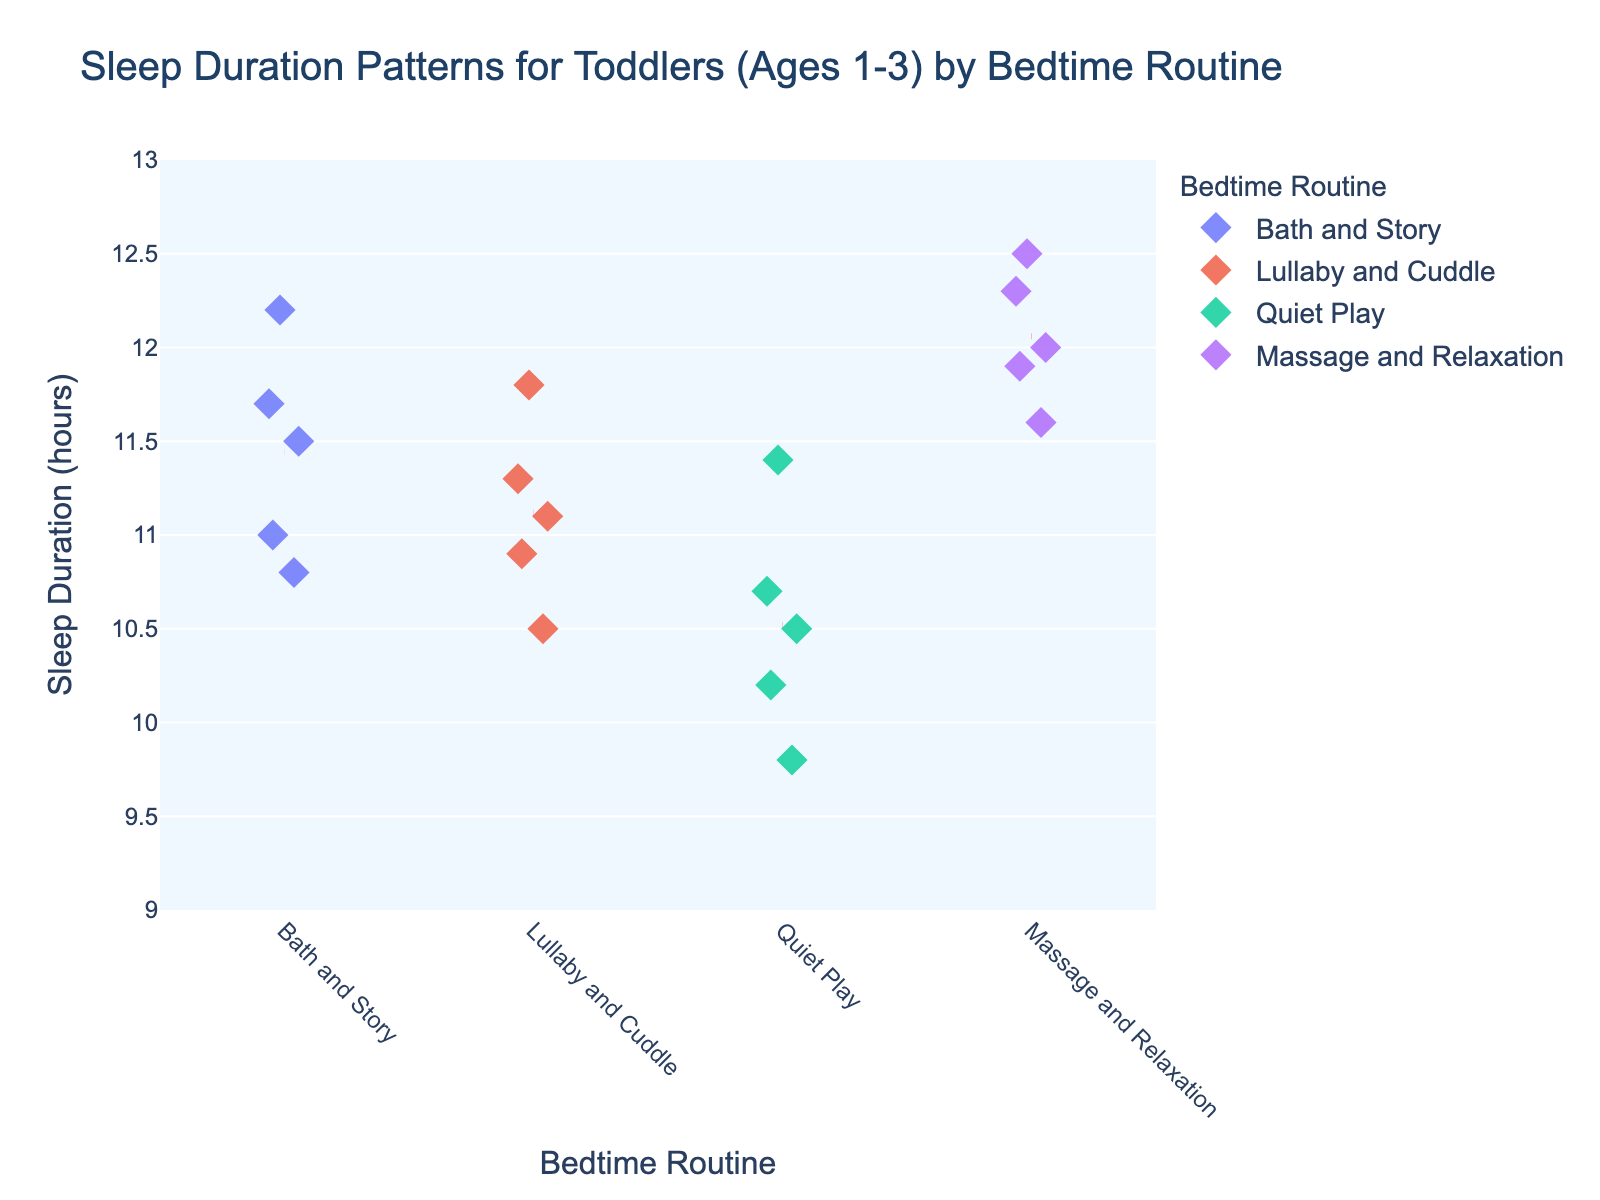What is the title of the plot? The title is usually found at the top of the plot, and in this case, it is written clearly.
Answer: Sleep Duration Patterns for Toddlers (Ages 1-3) by Bedtime Routine How many data points are represented in the 'Bath and Story' routine? Count the number of dots in the 'Bath and Story' category on the x-axis.
Answer: 5 What bedtime routine has the longest average sleep duration? Look for the bedtime routine with the red dashed mean line positioned highest on the y-axis indicating the longest sleep duration.
Answer: Massage and Relaxation What is the sleep duration range for the 'Quiet Play' bedtime routine? Identify the minimum and maximum points on the y-axis within the 'Quiet Play' category to establish the range.
Answer: 9.8 - 11.4 hours Which bedtime routine has the most varied sleep duration pattern? Observe which bedtime routine has points spread the widest across the y-axis.
Answer: Quiet Play How does the average sleep duration of 'Lullaby and Cuddle' compare to 'Bath and Story'? Compare the height of the red dashed mean lines for both routines on the y-axis.
Answer: Lullaby and Cuddle is slightly higher What are the different bedtime routines shown in the plot? Each bedtime routine is listed on the x-axis and has a distinctive color marker.
Answer: Bath and Story, Lullaby and Cuddle, Quiet Play, Massage and Relaxation Which bedtime routine's sleep duration data points vary the least? Look for the bedtime routine where the data points are closest together on the y-axis.
Answer: Massage and Relaxation What is the minimum sleep duration recorded for 'Bath and Story'? Find the lowest point marked in the 'Bath and Story' category on the y-axis.
Answer: 10.8 hours What bedtime routine has the highest sleep duration variability? Determine which bedtime routine has the largest difference between its maximum and minimum sleep duration data points.
Answer: Quiet Play 